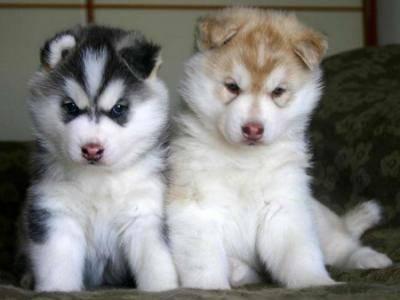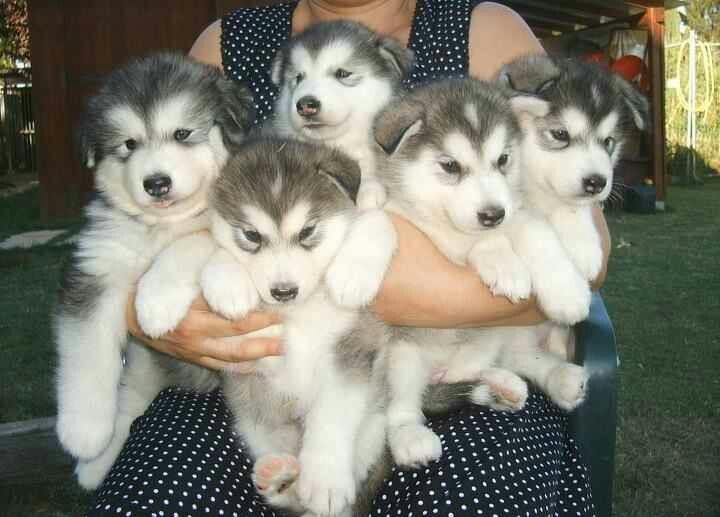The first image is the image on the left, the second image is the image on the right. Given the left and right images, does the statement "There are less than 5 dogs." hold true? Answer yes or no. No. The first image is the image on the left, the second image is the image on the right. Examine the images to the left and right. Is the description "At least one dog has its mouth open." accurate? Answer yes or no. No. 